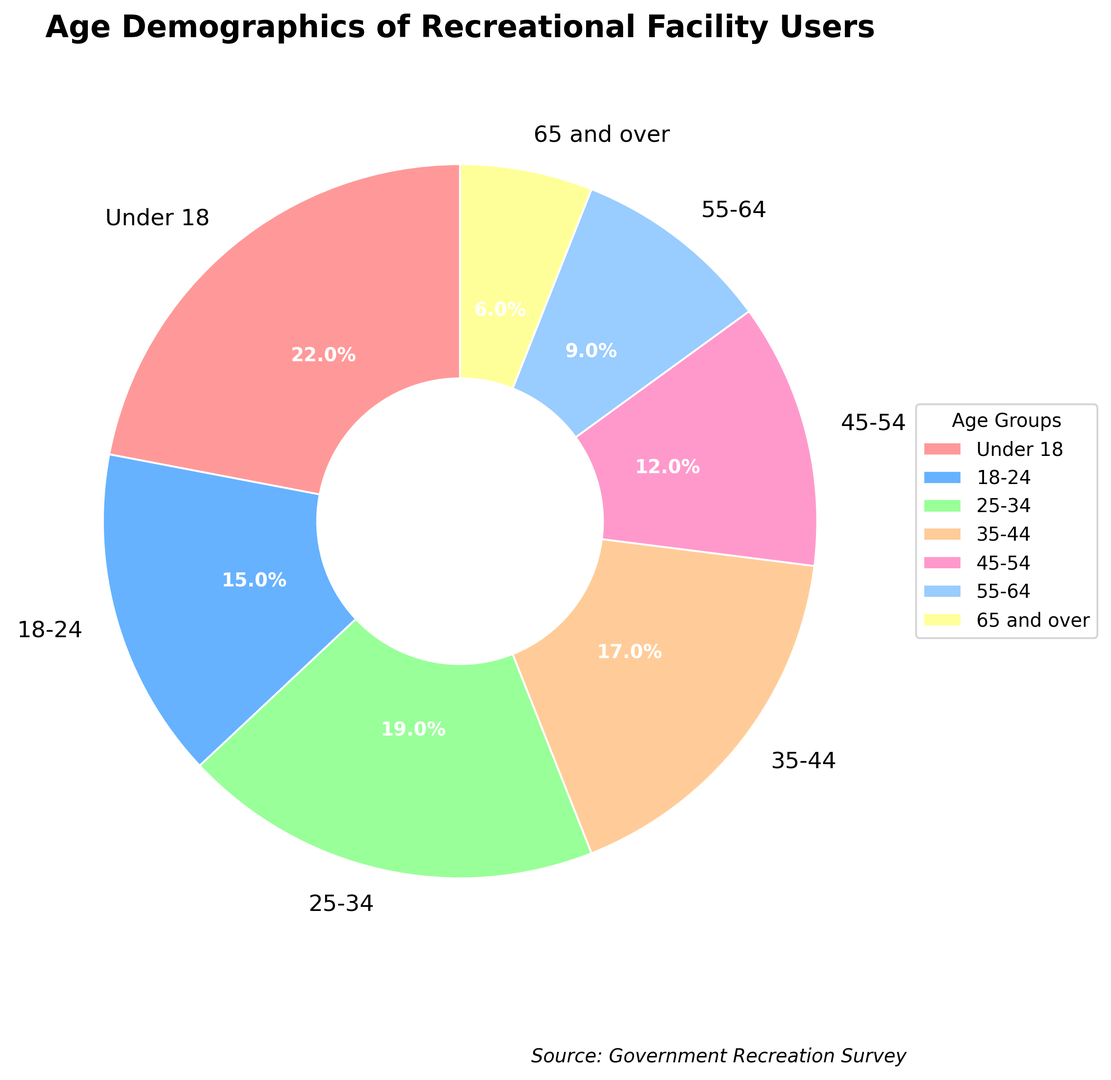what is the percentage of recreational facility users under 18? The slice of the pie chart labeled "Under 18" reads "22%", meaning that 22% of the users belong to this age group.
Answer: 22% which age group has the smallest representation in the pie chart? The slice labeled "65 and over" has the smallest percentage showing "6%", indicating it has the smallest representation.
Answer: 65 and over how much larger is the percentage of users aged 25-34 compared to those aged 55-64? The percentage for the 25-34 age group is 19%, and for the 55-64 age group, it is 9%. The difference can be calculated as 19% - 9% = 10%.
Answer: 10% which age group constitutes a combined 34% of the recreational facility users? The pie chart shows that the 18-24 and 35-44 age groups have percentages of 15% and 19% respectively. Adding them together (15% + 19%) gives us 34%.
Answer: 18-24 and 35-44 is the percentage of users aged 18-24 greater than that of users aged 35-44? The percentage for the 18-24 age group is 15%, whereas for the 35-44 age group, it is 17%. Comparing these, 15% is less than 17%.
Answer: No how many age groups have a percentage representation greater than 15%? Looking at the pie chart, the age groups "Under 18" (22%), "25-34" (19%), and "35-44" (17%) each have representations greater than 15%. Therefore, there are 3 such age groups.
Answer: 3 which color represents the age group with exactly 12% of users? The pie chart shows the age group "45-54" with a 12% representation. This segment is depicted in a color that appears to be pink.
Answer: Pink how does the percentage of users aged 45-54 compare to the percentage of users aged 18-24? The pie chart shows that the percentage for the 45-54 age group is 12%, while the percentage for the 18-24 age group is 15%. The 18-24 group is larger by 3%.
Answer: 18-24 is larger by 3% what is the combined percentage of the users aged under 18 and 25-34? The chart shows 22% for under 18 and 19% for 25-34. Adding these percentages, we get 22% + 19% = 41%.
Answer: 41% which age groups make up more than 50% of the pie chart when combined? Adding the percentages of age groups "Under 18" (22%), "25-34" (19%), and "35-44" (17%) results in 22% + 19% + 17% = 58%, which is more than 50%. These three age groups collectively make up the majority of the pie chart.
Answer: Under 18, 25-34, 35-44 